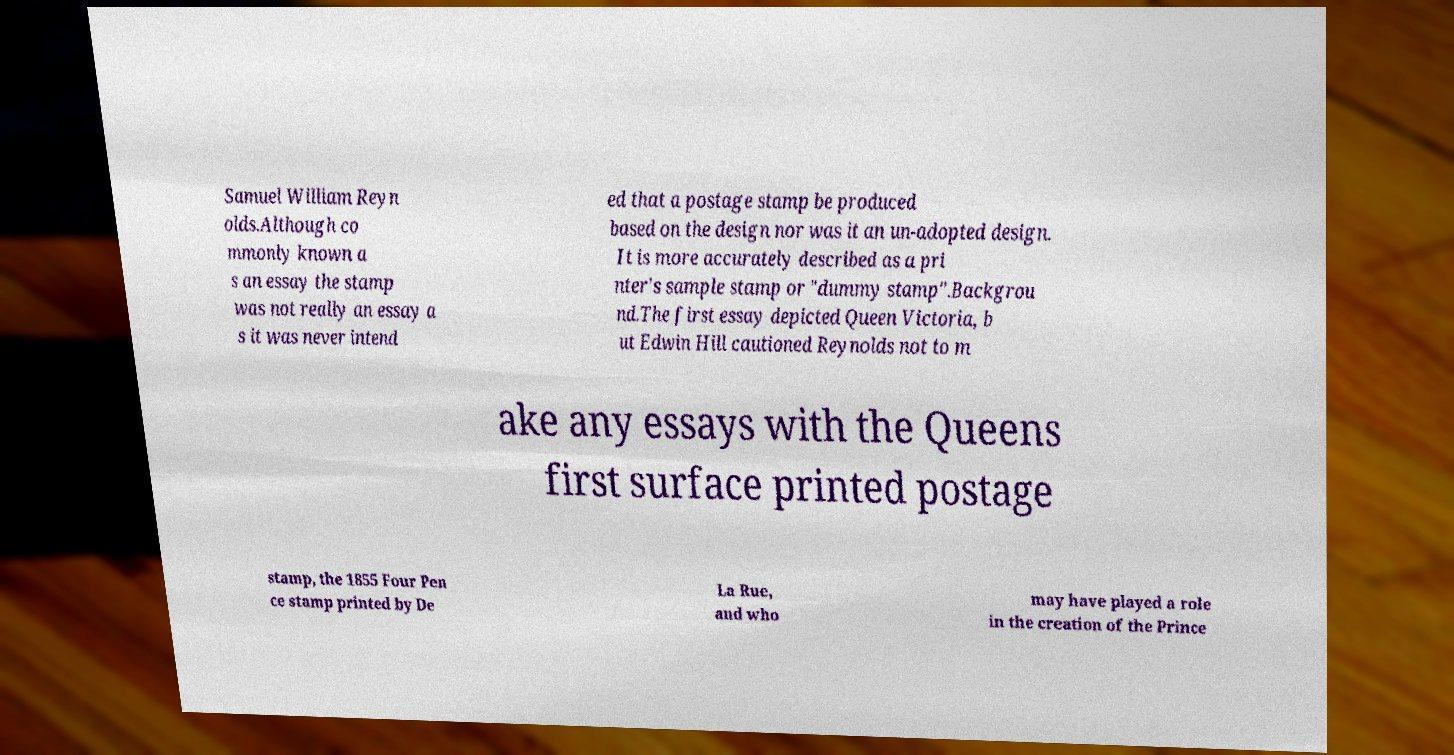For documentation purposes, I need the text within this image transcribed. Could you provide that? Samuel William Reyn olds.Although co mmonly known a s an essay the stamp was not really an essay a s it was never intend ed that a postage stamp be produced based on the design nor was it an un-adopted design. It is more accurately described as a pri nter's sample stamp or "dummy stamp".Backgrou nd.The first essay depicted Queen Victoria, b ut Edwin Hill cautioned Reynolds not to m ake any essays with the Queens first surface printed postage stamp, the 1855 Four Pen ce stamp printed by De La Rue, and who may have played a role in the creation of the Prince 